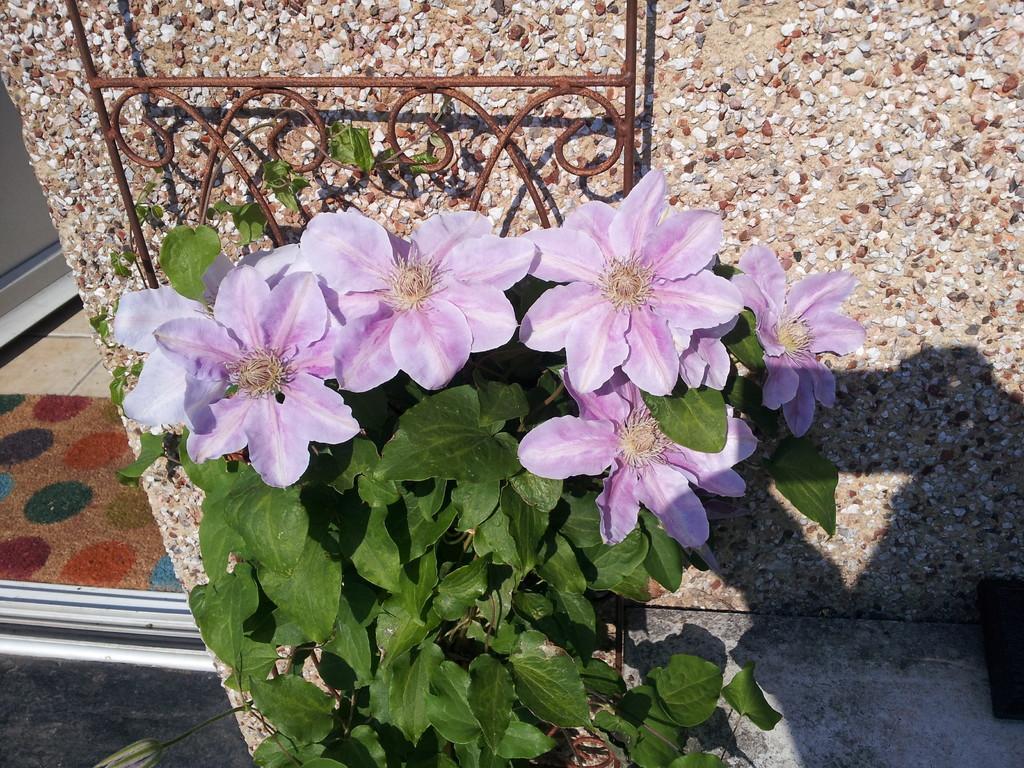In one or two sentences, can you explain what this image depicts? In this image we can see plant with flowers. In the background of the image there is wall. At the bottom of the image there is floor. To the left side of the image there is a doormat. 